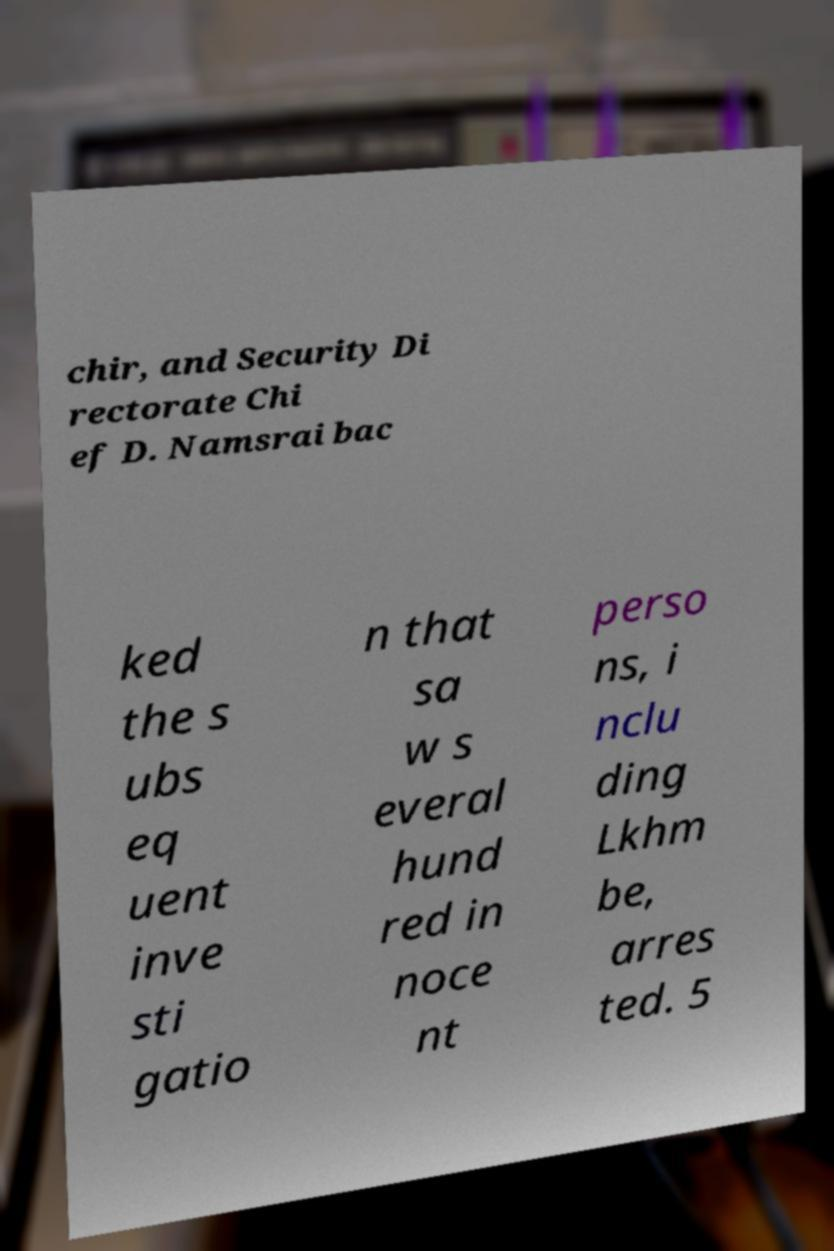Can you read and provide the text displayed in the image?This photo seems to have some interesting text. Can you extract and type it out for me? chir, and Security Di rectorate Chi ef D. Namsrai bac ked the s ubs eq uent inve sti gatio n that sa w s everal hund red in noce nt perso ns, i nclu ding Lkhm be, arres ted. 5 